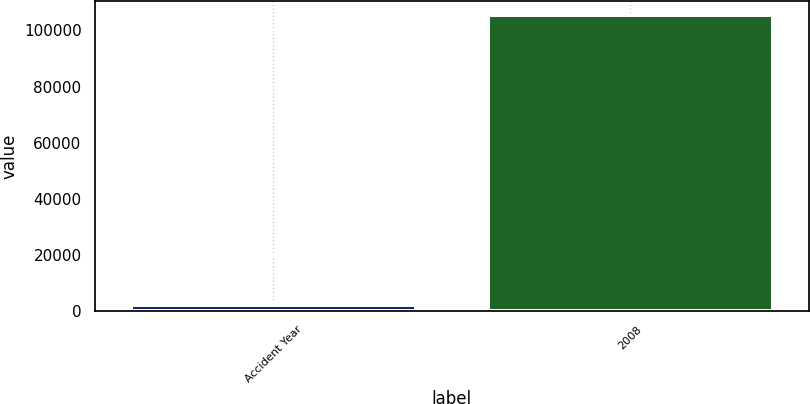<chart> <loc_0><loc_0><loc_500><loc_500><bar_chart><fcel>Accident Year<fcel>2008<nl><fcel>2015<fcel>105346<nl></chart> 